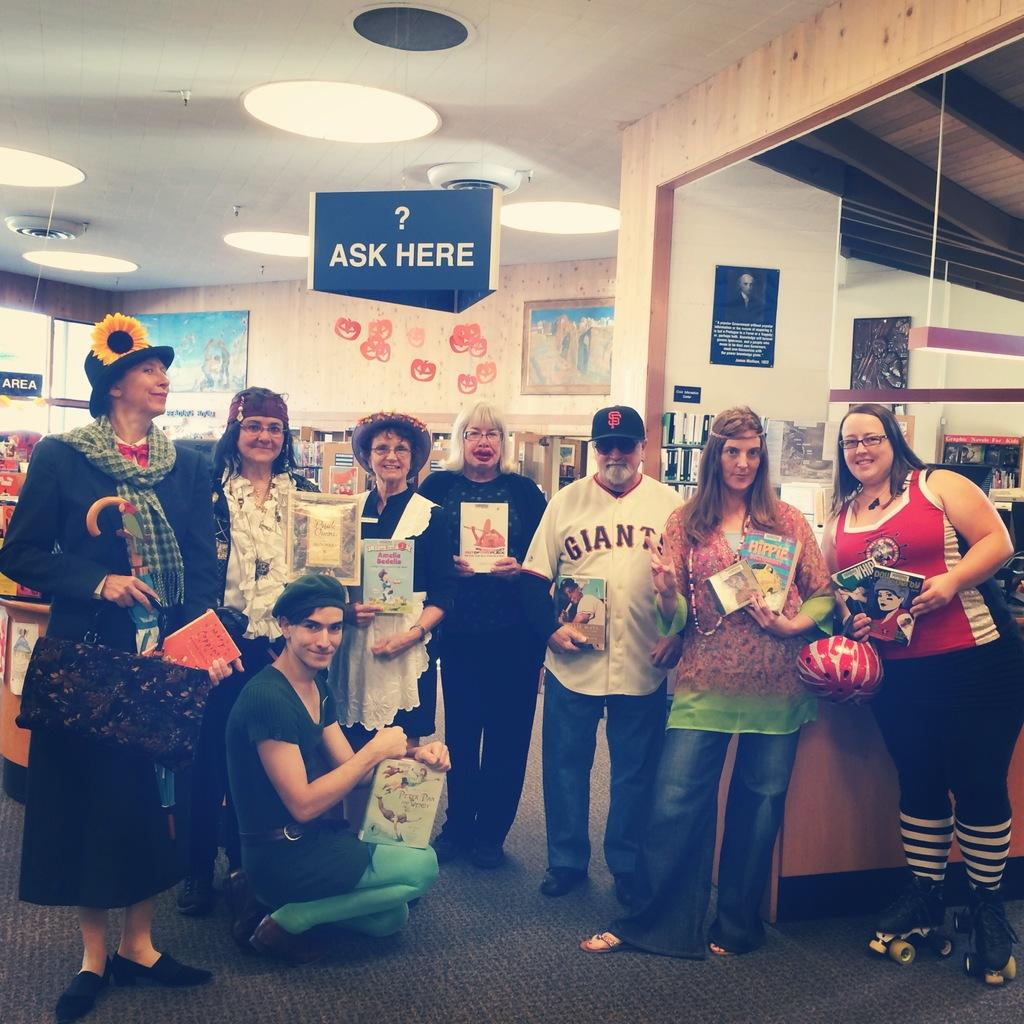<image>
Give a short and clear explanation of the subsequent image. A group of people in costume are holding books by an Ask Here sign in a store. 